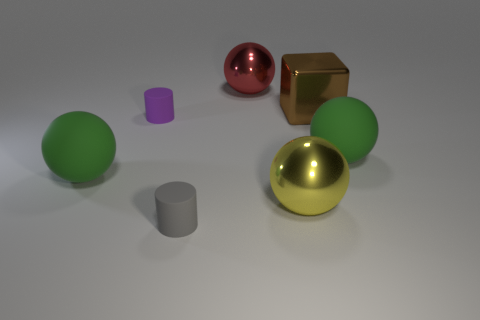There is a ball that is on the right side of the large red metal object and behind the yellow metallic object; what is its material?
Offer a very short reply. Rubber. How big is the shiny cube?
Ensure brevity in your answer.  Large. There is a matte cylinder in front of the green rubber ball that is on the right side of the tiny purple matte object; how many brown shiny blocks are left of it?
Make the answer very short. 0. What is the shape of the large green thing that is on the right side of the tiny rubber cylinder that is in front of the yellow ball?
Provide a succinct answer. Sphere. What size is the yellow thing that is the same shape as the red metallic thing?
Ensure brevity in your answer.  Large. There is a rubber sphere on the left side of the yellow metal ball; what is its color?
Make the answer very short. Green. The green thing on the left side of the big green object on the right side of the tiny matte object that is in front of the big yellow metallic object is made of what material?
Offer a terse response. Rubber. There is a matte ball that is right of the green rubber sphere that is left of the brown cube; what size is it?
Your answer should be compact. Large. The other small object that is the same shape as the tiny purple rubber object is what color?
Provide a short and direct response. Gray. What number of big matte objects have the same color as the cube?
Your answer should be compact. 0. 